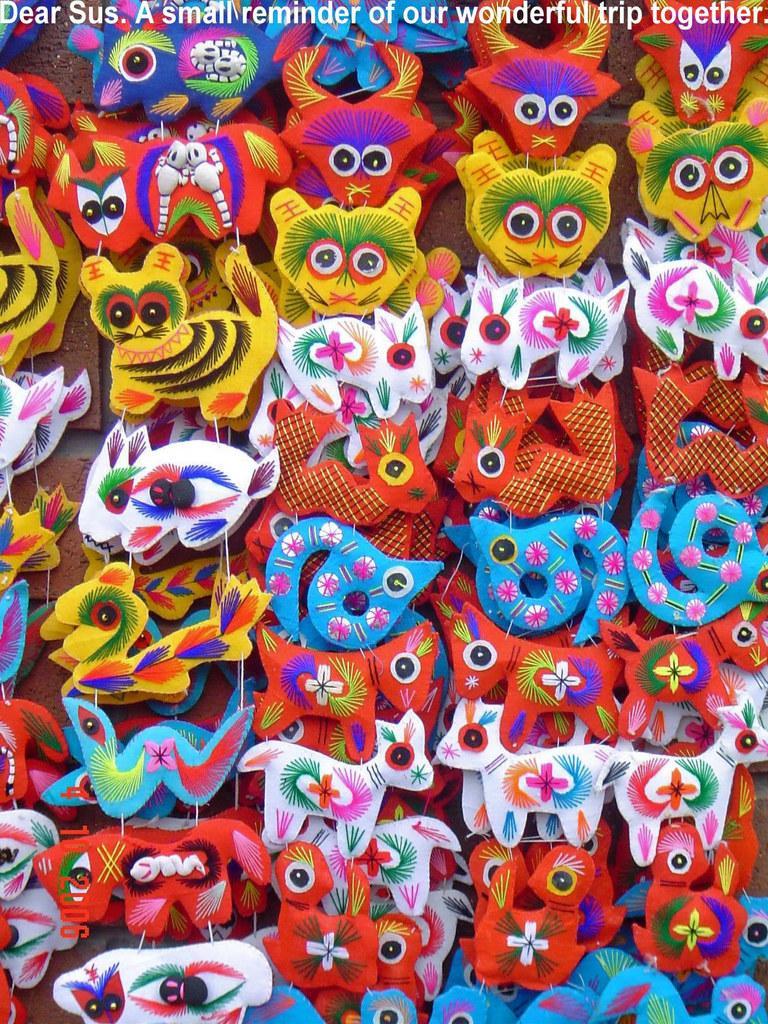Could you give a brief overview of what you see in this image? In this image we can see some decorative items. At the top something is written. 